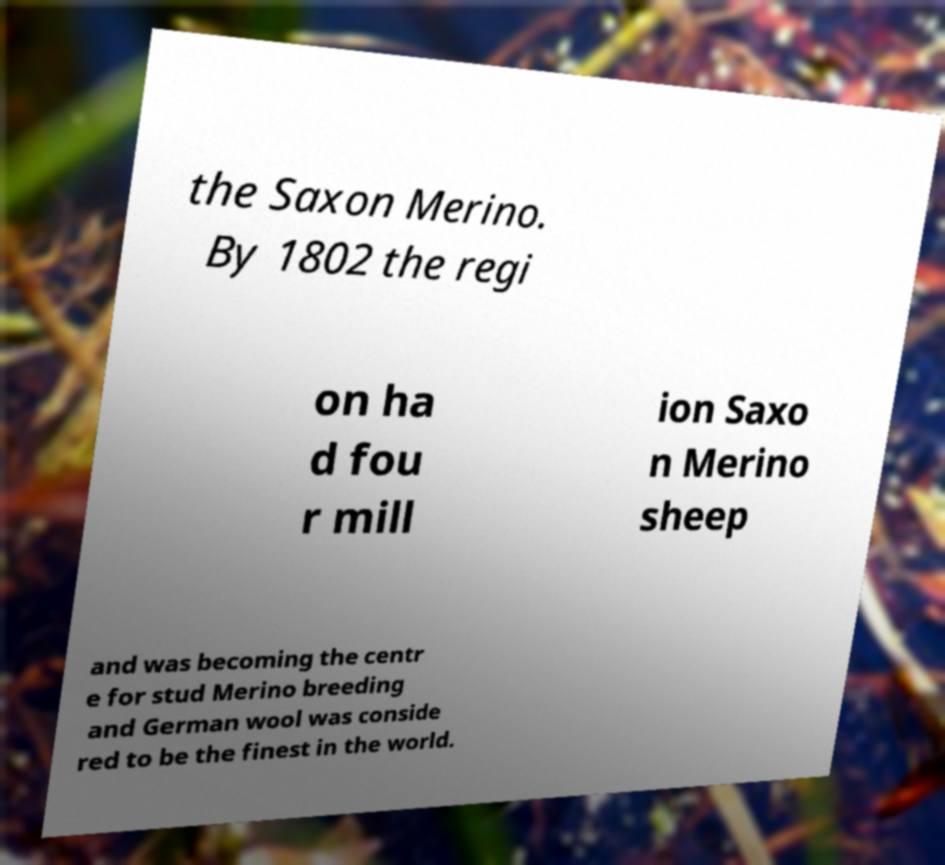Please read and relay the text visible in this image. What does it say? the Saxon Merino. By 1802 the regi on ha d fou r mill ion Saxo n Merino sheep and was becoming the centr e for stud Merino breeding and German wool was conside red to be the finest in the world. 